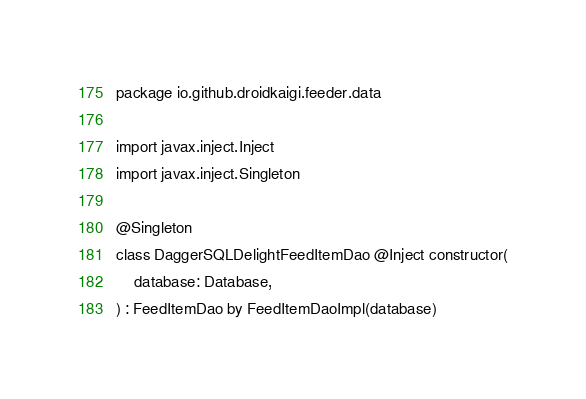Convert code to text. <code><loc_0><loc_0><loc_500><loc_500><_Kotlin_>package io.github.droidkaigi.feeder.data

import javax.inject.Inject
import javax.inject.Singleton

@Singleton
class DaggerSQLDelightFeedItemDao @Inject constructor(
    database: Database,
) : FeedItemDao by FeedItemDaoImpl(database)
</code> 